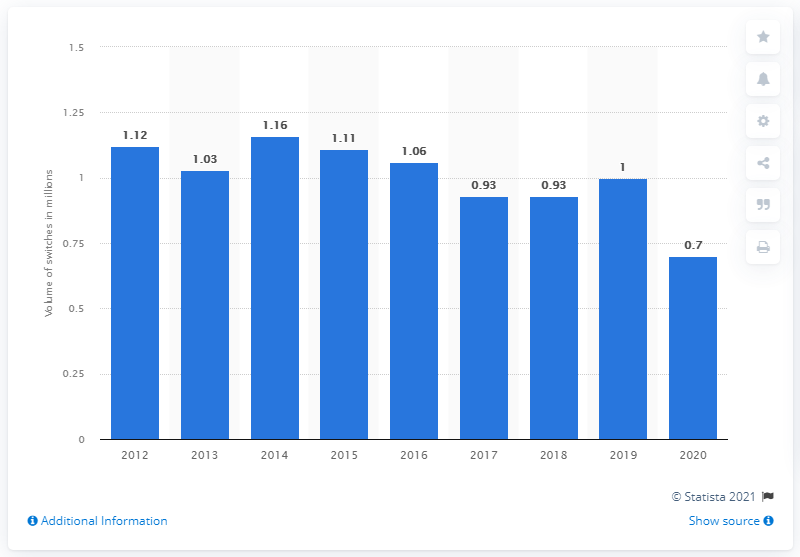Draw attention to some important aspects in this diagram. In 2014, a total of 1.16 million customers changed their primary bank account provider. In the year 2020, approximately 0.7% of customers switched their current bank account provider. 